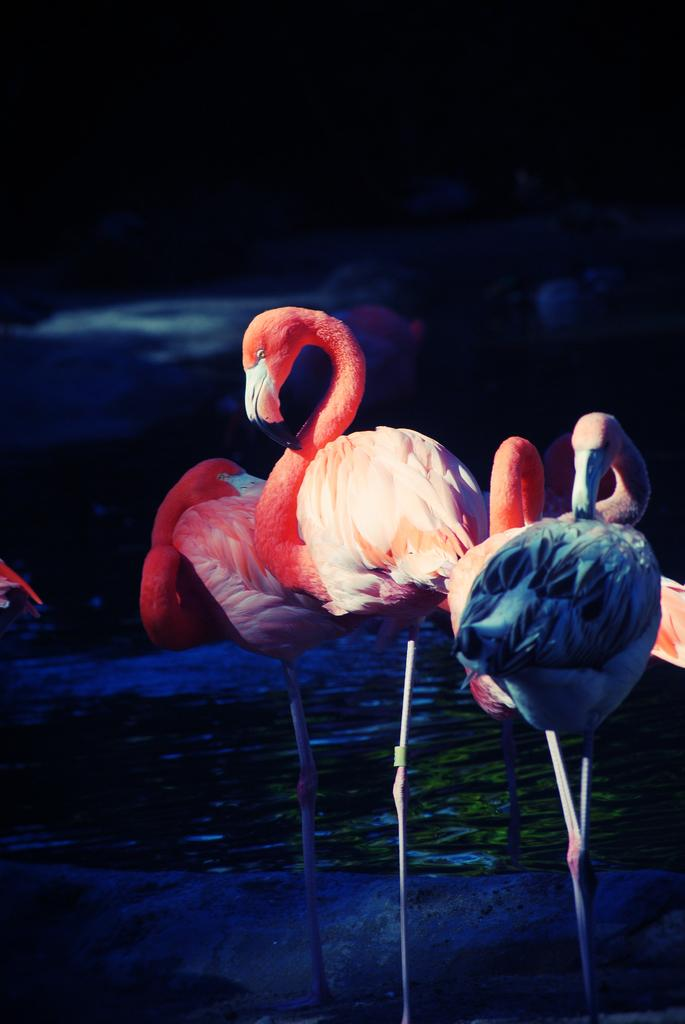What type of animals can be seen in the image? Birds can be seen in the image. What is visible in the background of the image? There is water visible in the background of the image. How would you describe the overall lighting in the image? The background of the image is dark. What type of support can be seen holding up the birds in the image? There is no support holding up the birds in the image; they are flying or perched on their own. 